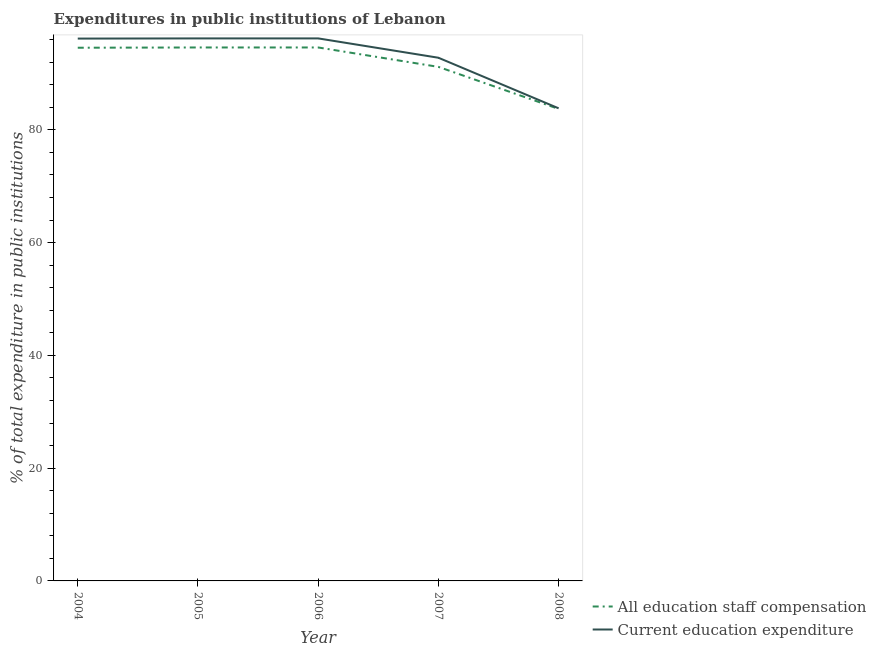How many different coloured lines are there?
Give a very brief answer. 2. Does the line corresponding to expenditure in education intersect with the line corresponding to expenditure in staff compensation?
Ensure brevity in your answer.  No. What is the expenditure in education in 2004?
Ensure brevity in your answer.  96.18. Across all years, what is the maximum expenditure in staff compensation?
Offer a very short reply. 94.6. Across all years, what is the minimum expenditure in staff compensation?
Your answer should be very brief. 83.71. In which year was the expenditure in staff compensation maximum?
Provide a succinct answer. 2006. In which year was the expenditure in staff compensation minimum?
Offer a very short reply. 2008. What is the total expenditure in education in the graph?
Your response must be concise. 465.21. What is the difference between the expenditure in staff compensation in 2005 and that in 2007?
Your response must be concise. 3.44. What is the difference between the expenditure in staff compensation in 2007 and the expenditure in education in 2005?
Ensure brevity in your answer.  -5.05. What is the average expenditure in staff compensation per year?
Offer a terse response. 91.73. In the year 2006, what is the difference between the expenditure in education and expenditure in staff compensation?
Your answer should be very brief. 1.61. In how many years, is the expenditure in education greater than 20 %?
Ensure brevity in your answer.  5. What is the ratio of the expenditure in education in 2005 to that in 2008?
Your answer should be very brief. 1.15. Is the expenditure in staff compensation in 2004 less than that in 2006?
Your response must be concise. Yes. Is the difference between the expenditure in education in 2004 and 2008 greater than the difference between the expenditure in staff compensation in 2004 and 2008?
Your response must be concise. Yes. What is the difference between the highest and the second highest expenditure in staff compensation?
Make the answer very short. 0. What is the difference between the highest and the lowest expenditure in education?
Give a very brief answer. 12.4. Is the sum of the expenditure in education in 2005 and 2007 greater than the maximum expenditure in staff compensation across all years?
Your answer should be compact. Yes. Does the expenditure in staff compensation monotonically increase over the years?
Your response must be concise. No. Is the expenditure in education strictly greater than the expenditure in staff compensation over the years?
Make the answer very short. Yes. Is the expenditure in staff compensation strictly less than the expenditure in education over the years?
Your response must be concise. Yes. What is the difference between two consecutive major ticks on the Y-axis?
Give a very brief answer. 20. How many legend labels are there?
Provide a succinct answer. 2. What is the title of the graph?
Your answer should be compact. Expenditures in public institutions of Lebanon. What is the label or title of the X-axis?
Keep it short and to the point. Year. What is the label or title of the Y-axis?
Your answer should be very brief. % of total expenditure in public institutions. What is the % of total expenditure in public institutions in All education staff compensation in 2004?
Give a very brief answer. 94.56. What is the % of total expenditure in public institutions in Current education expenditure in 2004?
Offer a terse response. 96.18. What is the % of total expenditure in public institutions in All education staff compensation in 2005?
Give a very brief answer. 94.6. What is the % of total expenditure in public institutions in Current education expenditure in 2005?
Your response must be concise. 96.21. What is the % of total expenditure in public institutions in All education staff compensation in 2006?
Make the answer very short. 94.6. What is the % of total expenditure in public institutions in Current education expenditure in 2006?
Offer a terse response. 96.21. What is the % of total expenditure in public institutions in All education staff compensation in 2007?
Your answer should be very brief. 91.16. What is the % of total expenditure in public institutions in Current education expenditure in 2007?
Your response must be concise. 92.78. What is the % of total expenditure in public institutions in All education staff compensation in 2008?
Your answer should be very brief. 83.71. What is the % of total expenditure in public institutions in Current education expenditure in 2008?
Your answer should be very brief. 83.82. Across all years, what is the maximum % of total expenditure in public institutions in All education staff compensation?
Your answer should be compact. 94.6. Across all years, what is the maximum % of total expenditure in public institutions in Current education expenditure?
Provide a succinct answer. 96.21. Across all years, what is the minimum % of total expenditure in public institutions of All education staff compensation?
Keep it short and to the point. 83.71. Across all years, what is the minimum % of total expenditure in public institutions of Current education expenditure?
Provide a succinct answer. 83.82. What is the total % of total expenditure in public institutions of All education staff compensation in the graph?
Offer a terse response. 458.64. What is the total % of total expenditure in public institutions in Current education expenditure in the graph?
Provide a succinct answer. 465.21. What is the difference between the % of total expenditure in public institutions of All education staff compensation in 2004 and that in 2005?
Give a very brief answer. -0.05. What is the difference between the % of total expenditure in public institutions of Current education expenditure in 2004 and that in 2005?
Give a very brief answer. -0.03. What is the difference between the % of total expenditure in public institutions of All education staff compensation in 2004 and that in 2006?
Give a very brief answer. -0.05. What is the difference between the % of total expenditure in public institutions in Current education expenditure in 2004 and that in 2006?
Offer a terse response. -0.03. What is the difference between the % of total expenditure in public institutions in All education staff compensation in 2004 and that in 2007?
Offer a terse response. 3.4. What is the difference between the % of total expenditure in public institutions of Current education expenditure in 2004 and that in 2007?
Offer a very short reply. 3.4. What is the difference between the % of total expenditure in public institutions of All education staff compensation in 2004 and that in 2008?
Your answer should be compact. 10.85. What is the difference between the % of total expenditure in public institutions in Current education expenditure in 2004 and that in 2008?
Make the answer very short. 12.37. What is the difference between the % of total expenditure in public institutions of All education staff compensation in 2005 and that in 2006?
Keep it short and to the point. -0. What is the difference between the % of total expenditure in public institutions of Current education expenditure in 2005 and that in 2006?
Ensure brevity in your answer.  -0. What is the difference between the % of total expenditure in public institutions of All education staff compensation in 2005 and that in 2007?
Give a very brief answer. 3.44. What is the difference between the % of total expenditure in public institutions of Current education expenditure in 2005 and that in 2007?
Give a very brief answer. 3.43. What is the difference between the % of total expenditure in public institutions of All education staff compensation in 2005 and that in 2008?
Keep it short and to the point. 10.9. What is the difference between the % of total expenditure in public institutions in Current education expenditure in 2005 and that in 2008?
Offer a very short reply. 12.4. What is the difference between the % of total expenditure in public institutions in All education staff compensation in 2006 and that in 2007?
Offer a terse response. 3.44. What is the difference between the % of total expenditure in public institutions in Current education expenditure in 2006 and that in 2007?
Give a very brief answer. 3.43. What is the difference between the % of total expenditure in public institutions of All education staff compensation in 2006 and that in 2008?
Keep it short and to the point. 10.9. What is the difference between the % of total expenditure in public institutions in Current education expenditure in 2006 and that in 2008?
Keep it short and to the point. 12.4. What is the difference between the % of total expenditure in public institutions of All education staff compensation in 2007 and that in 2008?
Provide a succinct answer. 7.46. What is the difference between the % of total expenditure in public institutions in Current education expenditure in 2007 and that in 2008?
Provide a succinct answer. 8.97. What is the difference between the % of total expenditure in public institutions of All education staff compensation in 2004 and the % of total expenditure in public institutions of Current education expenditure in 2005?
Your answer should be compact. -1.65. What is the difference between the % of total expenditure in public institutions in All education staff compensation in 2004 and the % of total expenditure in public institutions in Current education expenditure in 2006?
Provide a short and direct response. -1.65. What is the difference between the % of total expenditure in public institutions of All education staff compensation in 2004 and the % of total expenditure in public institutions of Current education expenditure in 2007?
Ensure brevity in your answer.  1.78. What is the difference between the % of total expenditure in public institutions in All education staff compensation in 2004 and the % of total expenditure in public institutions in Current education expenditure in 2008?
Ensure brevity in your answer.  10.74. What is the difference between the % of total expenditure in public institutions of All education staff compensation in 2005 and the % of total expenditure in public institutions of Current education expenditure in 2006?
Give a very brief answer. -1.61. What is the difference between the % of total expenditure in public institutions of All education staff compensation in 2005 and the % of total expenditure in public institutions of Current education expenditure in 2007?
Make the answer very short. 1.82. What is the difference between the % of total expenditure in public institutions of All education staff compensation in 2005 and the % of total expenditure in public institutions of Current education expenditure in 2008?
Offer a very short reply. 10.79. What is the difference between the % of total expenditure in public institutions in All education staff compensation in 2006 and the % of total expenditure in public institutions in Current education expenditure in 2007?
Give a very brief answer. 1.82. What is the difference between the % of total expenditure in public institutions in All education staff compensation in 2006 and the % of total expenditure in public institutions in Current education expenditure in 2008?
Offer a terse response. 10.79. What is the difference between the % of total expenditure in public institutions in All education staff compensation in 2007 and the % of total expenditure in public institutions in Current education expenditure in 2008?
Offer a very short reply. 7.35. What is the average % of total expenditure in public institutions of All education staff compensation per year?
Your answer should be very brief. 91.73. What is the average % of total expenditure in public institutions of Current education expenditure per year?
Your answer should be compact. 93.04. In the year 2004, what is the difference between the % of total expenditure in public institutions in All education staff compensation and % of total expenditure in public institutions in Current education expenditure?
Your response must be concise. -1.62. In the year 2005, what is the difference between the % of total expenditure in public institutions of All education staff compensation and % of total expenditure in public institutions of Current education expenditure?
Keep it short and to the point. -1.61. In the year 2006, what is the difference between the % of total expenditure in public institutions of All education staff compensation and % of total expenditure in public institutions of Current education expenditure?
Offer a terse response. -1.61. In the year 2007, what is the difference between the % of total expenditure in public institutions of All education staff compensation and % of total expenditure in public institutions of Current education expenditure?
Offer a terse response. -1.62. In the year 2008, what is the difference between the % of total expenditure in public institutions in All education staff compensation and % of total expenditure in public institutions in Current education expenditure?
Your answer should be very brief. -0.11. What is the ratio of the % of total expenditure in public institutions of All education staff compensation in 2004 to that in 2005?
Offer a terse response. 1. What is the ratio of the % of total expenditure in public institutions of All education staff compensation in 2004 to that in 2007?
Offer a very short reply. 1.04. What is the ratio of the % of total expenditure in public institutions in Current education expenditure in 2004 to that in 2007?
Give a very brief answer. 1.04. What is the ratio of the % of total expenditure in public institutions of All education staff compensation in 2004 to that in 2008?
Your answer should be very brief. 1.13. What is the ratio of the % of total expenditure in public institutions in Current education expenditure in 2004 to that in 2008?
Provide a succinct answer. 1.15. What is the ratio of the % of total expenditure in public institutions of All education staff compensation in 2005 to that in 2007?
Ensure brevity in your answer.  1.04. What is the ratio of the % of total expenditure in public institutions in All education staff compensation in 2005 to that in 2008?
Make the answer very short. 1.13. What is the ratio of the % of total expenditure in public institutions of Current education expenditure in 2005 to that in 2008?
Provide a succinct answer. 1.15. What is the ratio of the % of total expenditure in public institutions in All education staff compensation in 2006 to that in 2007?
Your answer should be compact. 1.04. What is the ratio of the % of total expenditure in public institutions of Current education expenditure in 2006 to that in 2007?
Provide a succinct answer. 1.04. What is the ratio of the % of total expenditure in public institutions in All education staff compensation in 2006 to that in 2008?
Your answer should be compact. 1.13. What is the ratio of the % of total expenditure in public institutions of Current education expenditure in 2006 to that in 2008?
Your response must be concise. 1.15. What is the ratio of the % of total expenditure in public institutions in All education staff compensation in 2007 to that in 2008?
Offer a terse response. 1.09. What is the ratio of the % of total expenditure in public institutions of Current education expenditure in 2007 to that in 2008?
Provide a succinct answer. 1.11. What is the difference between the highest and the second highest % of total expenditure in public institutions of Current education expenditure?
Your response must be concise. 0. What is the difference between the highest and the lowest % of total expenditure in public institutions of All education staff compensation?
Your answer should be compact. 10.9. What is the difference between the highest and the lowest % of total expenditure in public institutions in Current education expenditure?
Provide a short and direct response. 12.4. 